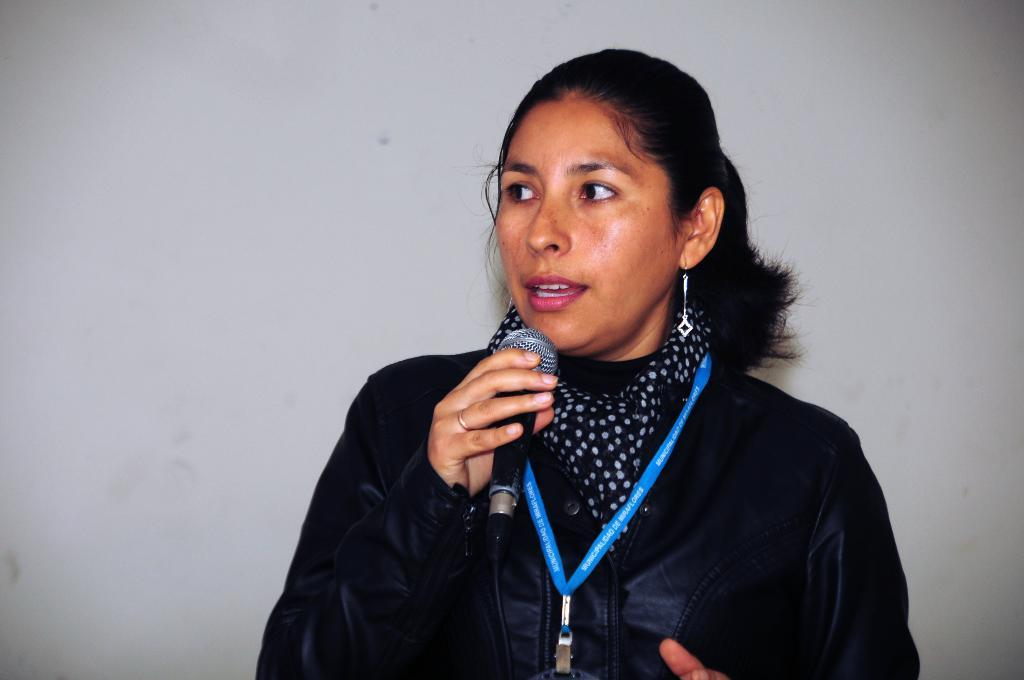Who is the main subject in the image? There is a lady in the image. What is the lady wearing? The lady is wearing a black jacket. What object is the lady holding in the image? The lady is holding a microphone (mic). What is the lady doing in the image? The lady is speaking. How many girls are present in the image? The image only features one lady, not multiple girls. What type of mist can be seen surrounding the lady in the image? There is no mist present in the image; it is a clear scene with the lady holding a microphone and speaking. 